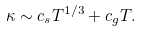<formula> <loc_0><loc_0><loc_500><loc_500>\kappa \sim c _ { s } T ^ { 1 / 3 } + c _ { g } T .</formula> 